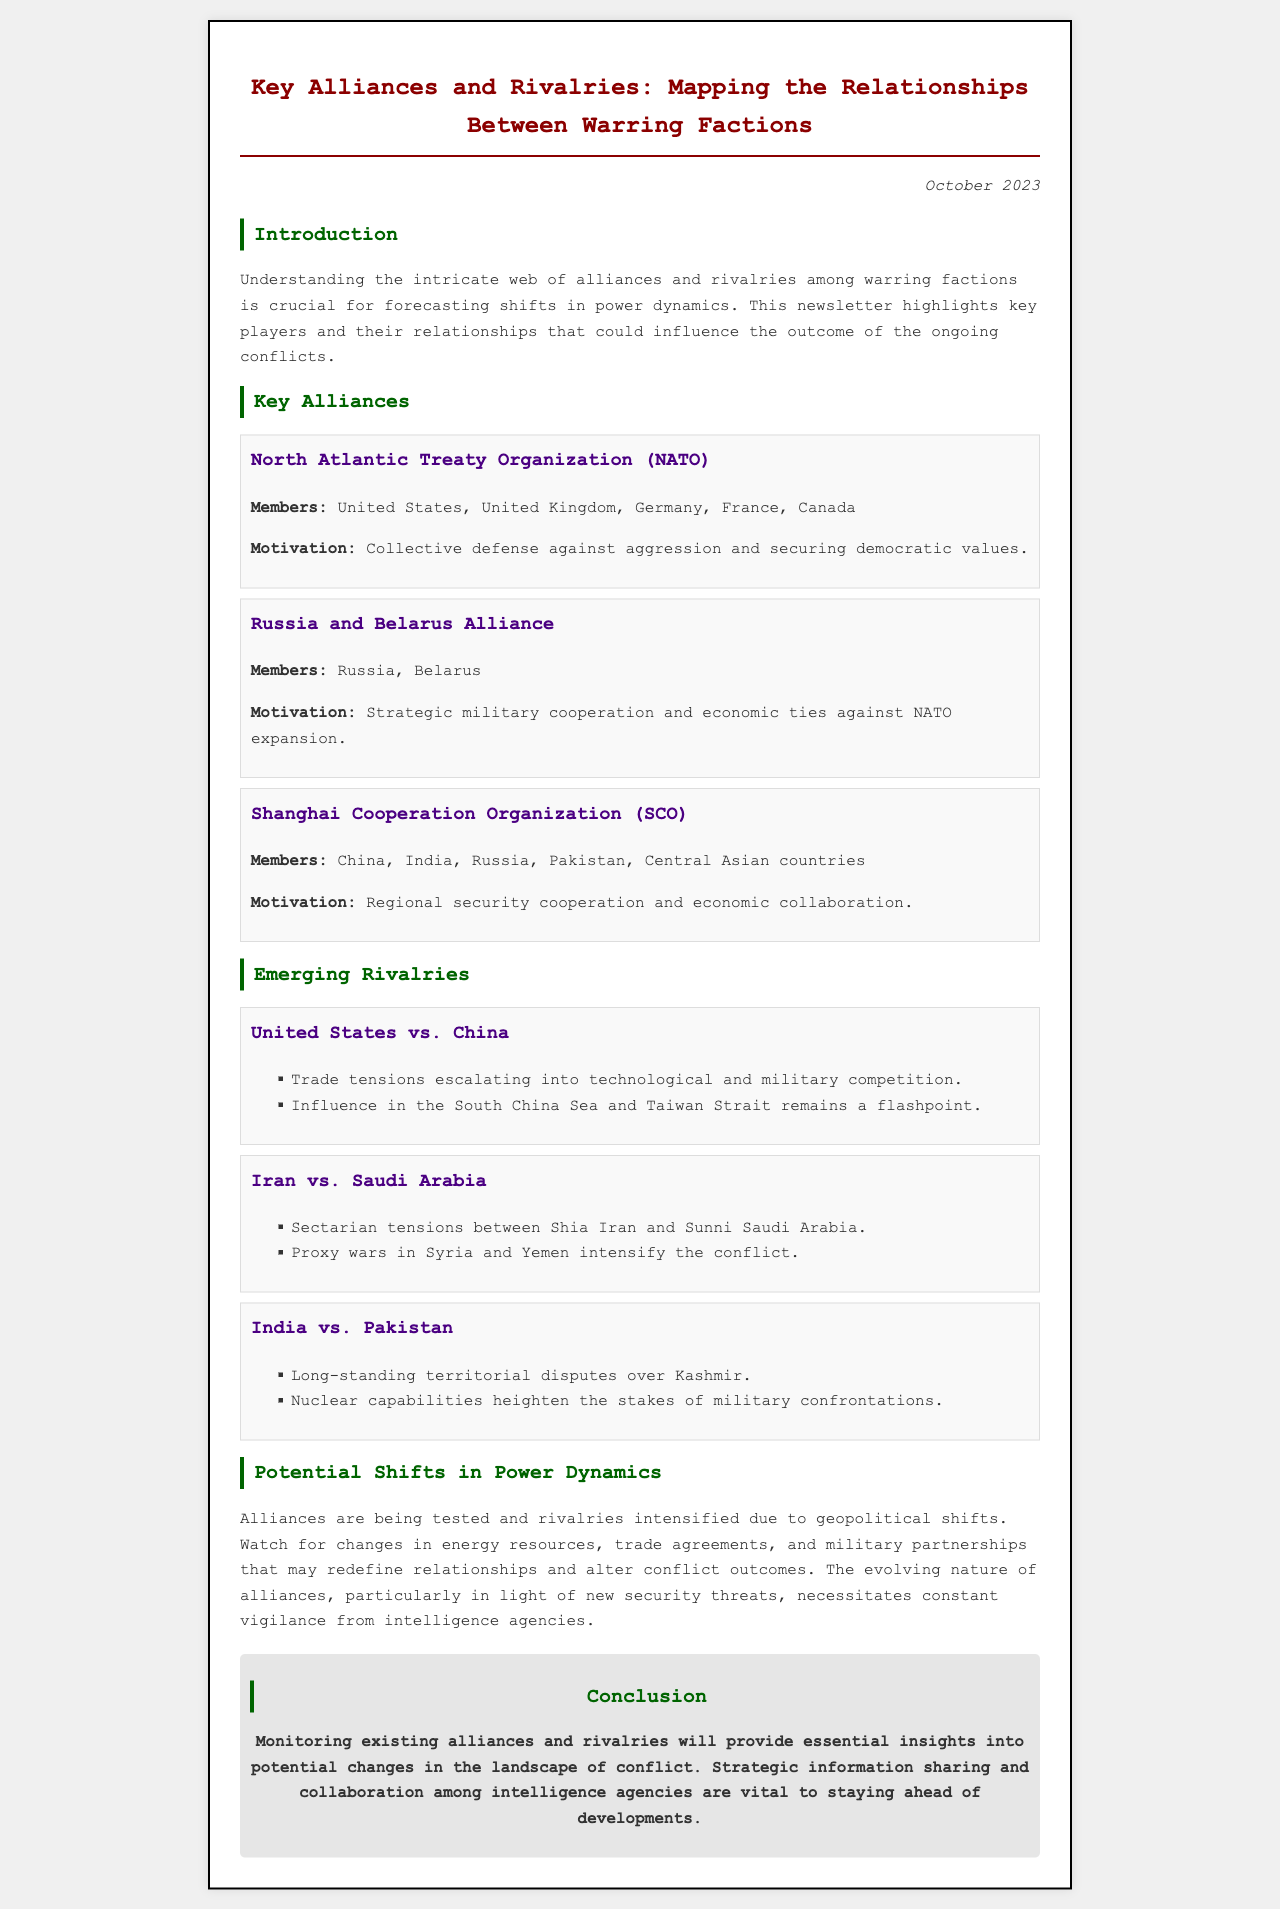What is the title of the newsletter? The title is the main heading of the document, which indicates the focus of the content.
Answer: Key Alliances and Rivalries: Mapping the Relationships Between Warring Factions What is the date of the newsletter? The date appears in the header section of the document and indicates the publication time.
Answer: October 2023 What is the motivation behind NATO? The motivation is stated under the NATO alliance section, explaining the purpose of this grouping.
Answer: Collective defense against aggression and securing democratic values Who are the members of the Shanghai Cooperation Organization? Members are listed within the SCO alliance section, detailing the countries involved.
Answer: China, India, Russia, Pakistan, Central Asian countries What are the key rivalries noted in the document? The document lists significant rivalries that could impact power dynamics, highlighting specific conflicts.
Answer: United States vs. China, Iran vs. Saudi Arabia, India vs. Pakistan What is a potential trigger for the United States and China rivalry? The document mentions specific factors that may escalate tensions between the two nations, focusing on key areas of conflict.
Answer: Trade tensions escalating into technological and military competition What does the conclusion highlight for intelligence agencies? The conclusion summarizes crucial information for agencies regarding the situation described in the newsletter.
Answer: Strategic information sharing and collaboration among intelligence agencies are vital to staying ahead of developments 